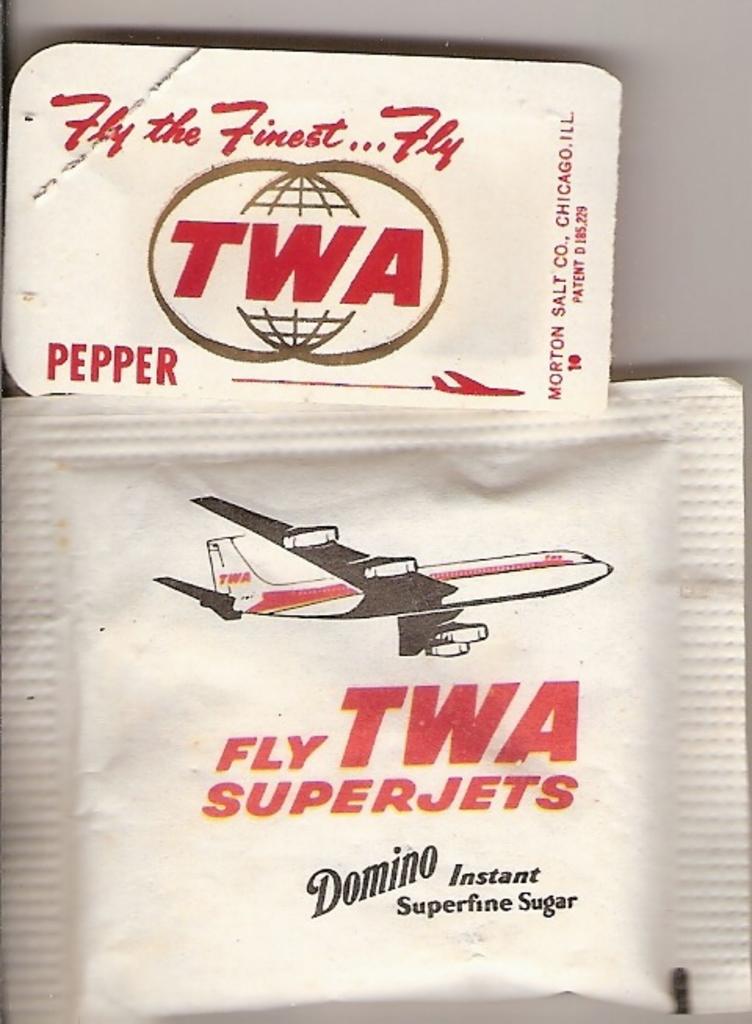What airline did these sugar packets come from?
Your answer should be compact. Twa. What is the brand name of sugar?
Ensure brevity in your answer.  Domino. 